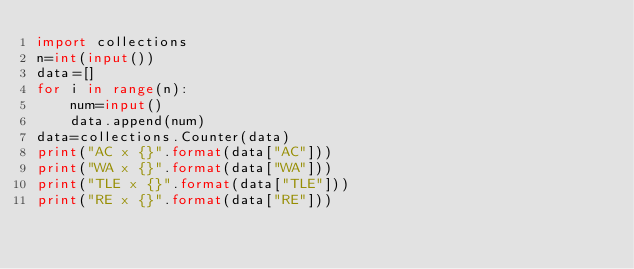Convert code to text. <code><loc_0><loc_0><loc_500><loc_500><_Python_>import collections
n=int(input())
data=[]
for i in range(n):
    num=input()
    data.append(num)
data=collections.Counter(data)
print("AC x {}".format(data["AC"]))
print("WA x {}".format(data["WA"]))
print("TLE x {}".format(data["TLE"]))
print("RE x {}".format(data["RE"]))</code> 